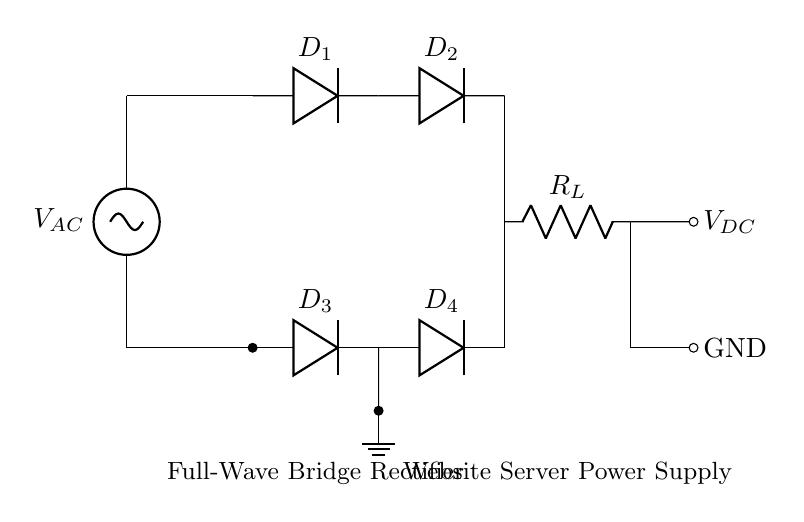What is the type of rectifier used in this circuit? The circuit diagram shows a full-wave bridge rectifier, which is characterized by four diodes arranged in a bridge configuration. This configuration allows for full-wave rectification of the AC input.
Answer: full-wave bridge rectifier How many diodes are in the circuit? Upon examining the circuit, there are four diodes labeled D1, D2, D3, and D4. Each of these diodes is part of the bridge rectifier that facilitates the conversion of AC to DC.
Answer: four What is the output voltage type from the rectifier? The output from the bridge rectifier is a direct current (DC) voltage, which can be seen as the voltage across the load resistor in the circuit.
Answer: DC What is the function of the load resistor in this circuit? The load resistor, labeled R_L, serves to provide a path for the output current and represents the load that the circuit supplies power to. It is essential for completing the circuit where the DC voltage is utilized.
Answer: provide a load for output current Why is a bridge rectifier preferred over a half-wave rectifier? A bridge rectifier allows for full-wave rectification, which means it converts both halves of the AC sine wave into usable DC voltage, resulting in higher efficiency and reduced ripple compared to a half-wave rectifier that only uses one half of the AC waveform.
Answer: higher efficiency What happens to the AC input voltage in this circuit? The AC input voltage is transformed into a pulsating DC voltage across the load, allowing for efficient power supply to the connected components. This transformation is achieved through the conduction of the diodes, allowing current to flow in only one direction.
Answer: transformed into pulsating DC voltage 